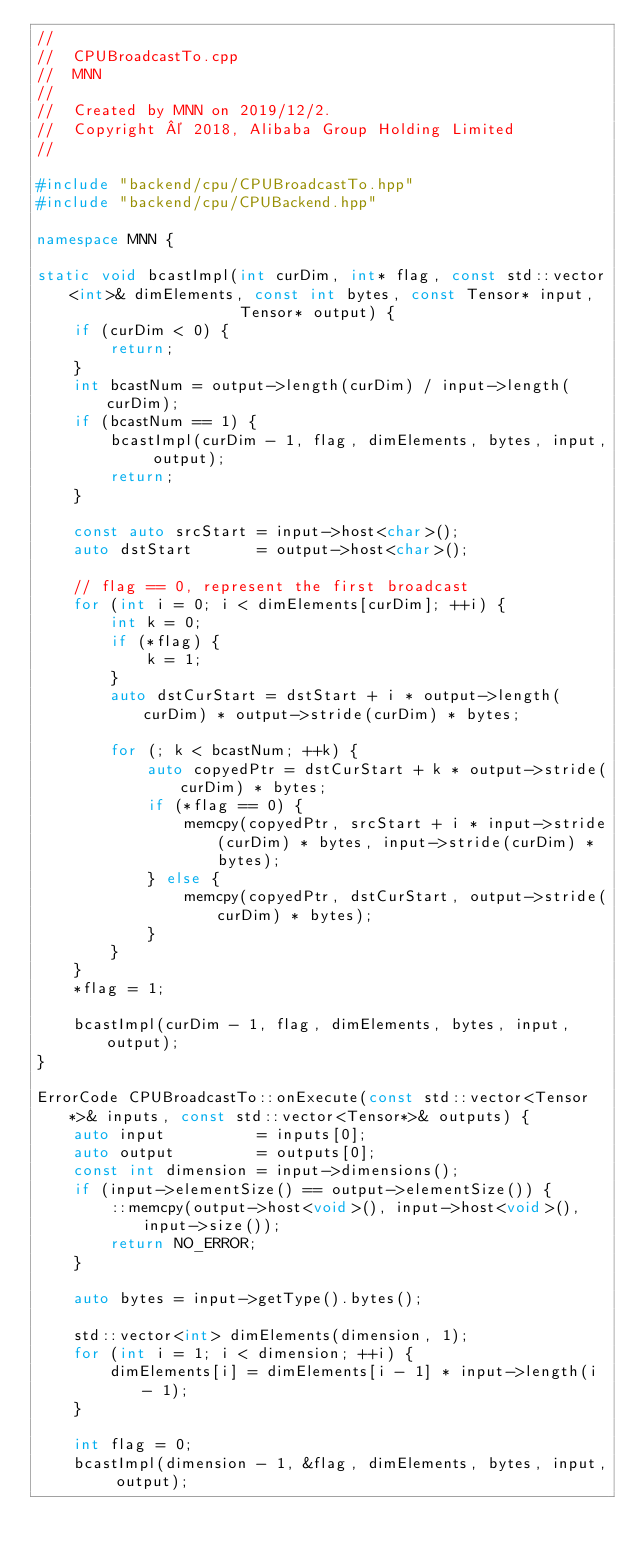<code> <loc_0><loc_0><loc_500><loc_500><_C++_>//
//  CPUBroadcastTo.cpp
//  MNN
//
//  Created by MNN on 2019/12/2.
//  Copyright © 2018, Alibaba Group Holding Limited
//

#include "backend/cpu/CPUBroadcastTo.hpp"
#include "backend/cpu/CPUBackend.hpp"

namespace MNN {

static void bcastImpl(int curDim, int* flag, const std::vector<int>& dimElements, const int bytes, const Tensor* input,
                      Tensor* output) {
    if (curDim < 0) {
        return;
    }
    int bcastNum = output->length(curDim) / input->length(curDim);
    if (bcastNum == 1) {
        bcastImpl(curDim - 1, flag, dimElements, bytes, input, output);
        return;
    }

    const auto srcStart = input->host<char>();
    auto dstStart       = output->host<char>();

    // flag == 0, represent the first broadcast
    for (int i = 0; i < dimElements[curDim]; ++i) {
        int k = 0;
        if (*flag) {
            k = 1;
        }
        auto dstCurStart = dstStart + i * output->length(curDim) * output->stride(curDim) * bytes;

        for (; k < bcastNum; ++k) {
            auto copyedPtr = dstCurStart + k * output->stride(curDim) * bytes;
            if (*flag == 0) {
                memcpy(copyedPtr, srcStart + i * input->stride(curDim) * bytes, input->stride(curDim) * bytes);
            } else {
                memcpy(copyedPtr, dstCurStart, output->stride(curDim) * bytes);
            }
        }
    }
    *flag = 1;

    bcastImpl(curDim - 1, flag, dimElements, bytes, input, output);
}

ErrorCode CPUBroadcastTo::onExecute(const std::vector<Tensor*>& inputs, const std::vector<Tensor*>& outputs) {
    auto input          = inputs[0];
    auto output         = outputs[0];
    const int dimension = input->dimensions();
    if (input->elementSize() == output->elementSize()) {
        ::memcpy(output->host<void>(), input->host<void>(), input->size());
        return NO_ERROR;
    }

    auto bytes = input->getType().bytes();

    std::vector<int> dimElements(dimension, 1);
    for (int i = 1; i < dimension; ++i) {
        dimElements[i] = dimElements[i - 1] * input->length(i - 1);
    }

    int flag = 0;
    bcastImpl(dimension - 1, &flag, dimElements, bytes, input, output);</code> 